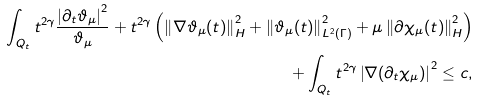<formula> <loc_0><loc_0><loc_500><loc_500>\int _ { Q _ { t } } { t ^ { 2 \gamma } \frac { \left | \partial _ { t } \vartheta _ { \mu } \right | ^ { 2 } } { \vartheta _ { \mu } } } + t ^ { 2 \gamma } \left ( \left \| \nabla \vartheta _ { \mu } ( t ) \right \| ^ { 2 } _ { H } + \left \| \vartheta _ { \mu } ( t ) \right \| ^ { 2 } _ { L ^ { 2 } ( \Gamma ) } + \mu \left \| \partial \chi _ { \mu } ( t ) \right \| ^ { 2 } _ { H } \right ) \\ + \int _ { Q _ { t } } { t ^ { 2 \gamma } \left | \nabla ( \partial _ { t } \chi _ { \mu } ) \right | ^ { 2 } } \leq c ,</formula> 